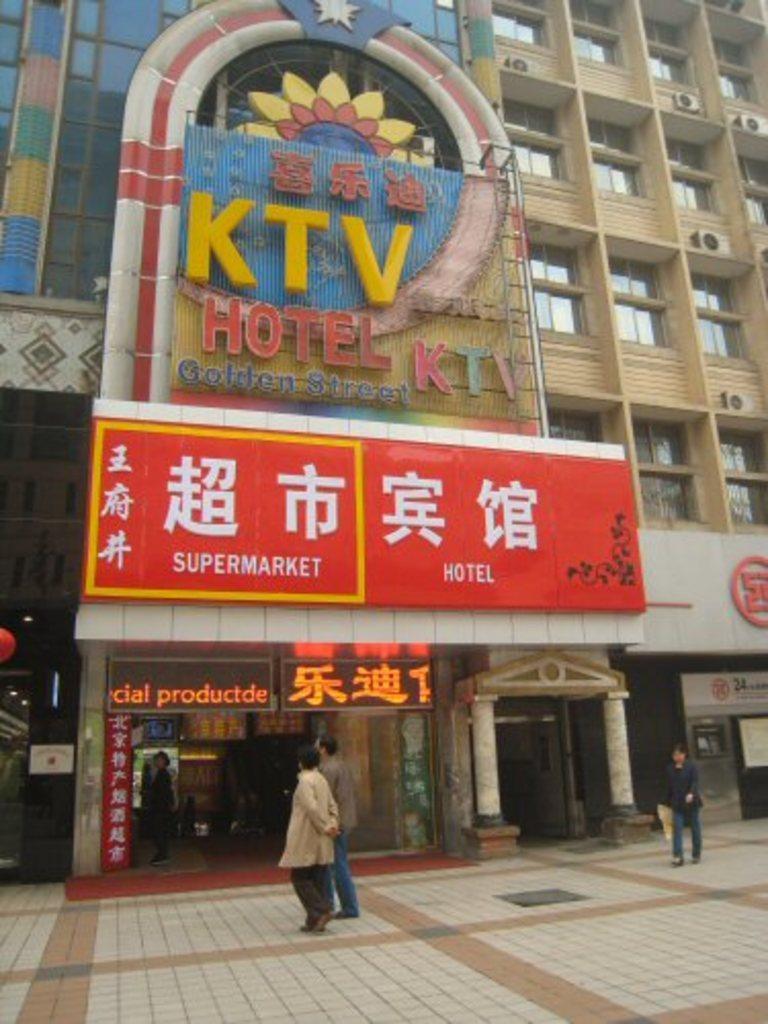Describe this image in one or two sentences. At the bottom of the image few people are standing and walking. Behind them there is a building, on the building there are some banners. 